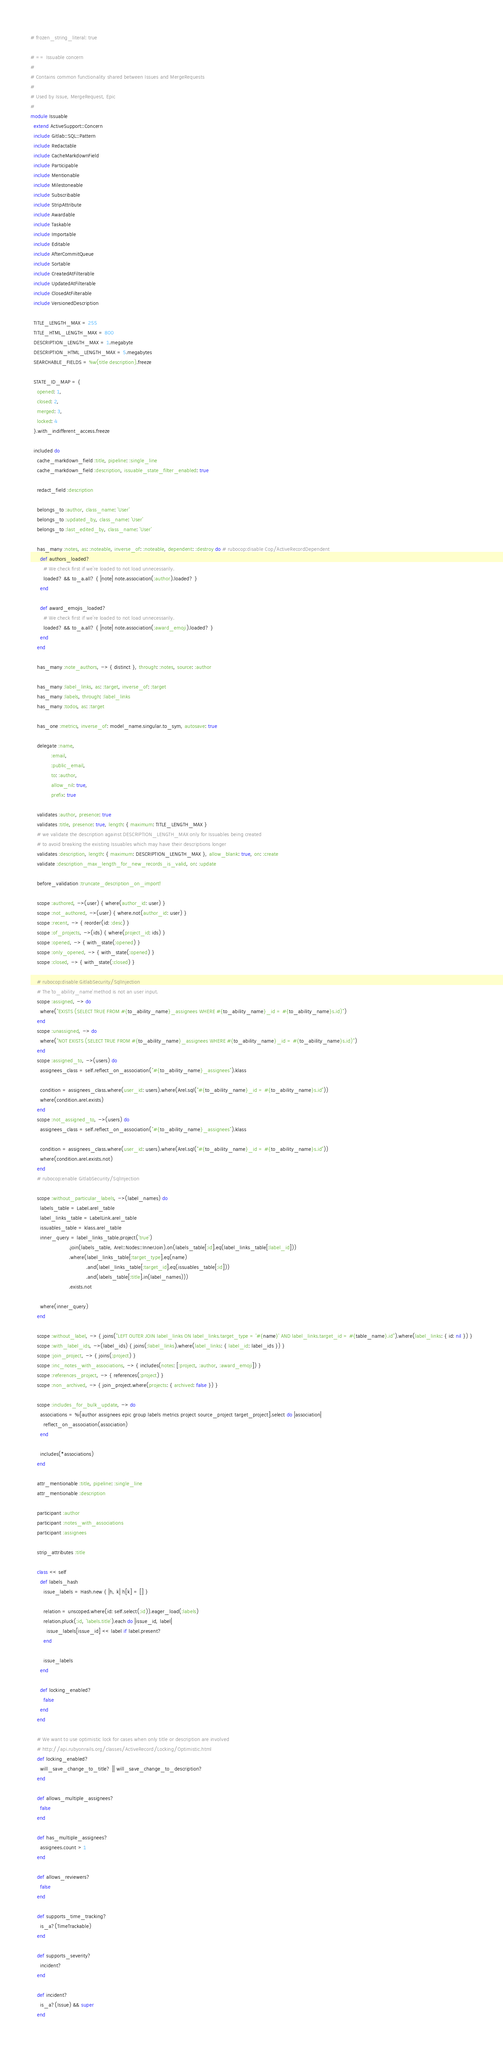<code> <loc_0><loc_0><loc_500><loc_500><_Ruby_># frozen_string_literal: true

# == Issuable concern
#
# Contains common functionality shared between Issues and MergeRequests
#
# Used by Issue, MergeRequest, Epic
#
module Issuable
  extend ActiveSupport::Concern
  include Gitlab::SQL::Pattern
  include Redactable
  include CacheMarkdownField
  include Participable
  include Mentionable
  include Milestoneable
  include Subscribable
  include StripAttribute
  include Awardable
  include Taskable
  include Importable
  include Editable
  include AfterCommitQueue
  include Sortable
  include CreatedAtFilterable
  include UpdatedAtFilterable
  include ClosedAtFilterable
  include VersionedDescription

  TITLE_LENGTH_MAX = 255
  TITLE_HTML_LENGTH_MAX = 800
  DESCRIPTION_LENGTH_MAX = 1.megabyte
  DESCRIPTION_HTML_LENGTH_MAX = 5.megabytes
  SEARCHABLE_FIELDS = %w(title description).freeze

  STATE_ID_MAP = {
    opened: 1,
    closed: 2,
    merged: 3,
    locked: 4
  }.with_indifferent_access.freeze

  included do
    cache_markdown_field :title, pipeline: :single_line
    cache_markdown_field :description, issuable_state_filter_enabled: true

    redact_field :description

    belongs_to :author, class_name: 'User'
    belongs_to :updated_by, class_name: 'User'
    belongs_to :last_edited_by, class_name: 'User'

    has_many :notes, as: :noteable, inverse_of: :noteable, dependent: :destroy do # rubocop:disable Cop/ActiveRecordDependent
      def authors_loaded?
        # We check first if we're loaded to not load unnecessarily.
        loaded? && to_a.all? { |note| note.association(:author).loaded? }
      end

      def award_emojis_loaded?
        # We check first if we're loaded to not load unnecessarily.
        loaded? && to_a.all? { |note| note.association(:award_emoji).loaded? }
      end
    end

    has_many :note_authors, -> { distinct }, through: :notes, source: :author

    has_many :label_links, as: :target, inverse_of: :target
    has_many :labels, through: :label_links
    has_many :todos, as: :target

    has_one :metrics, inverse_of: model_name.singular.to_sym, autosave: true

    delegate :name,
             :email,
             :public_email,
             to: :author,
             allow_nil: true,
             prefix: true

    validates :author, presence: true
    validates :title, presence: true, length: { maximum: TITLE_LENGTH_MAX }
    # we validate the description against DESCRIPTION_LENGTH_MAX only for Issuables being created
    # to avoid breaking the existing Issuables which may have their descriptions longer
    validates :description, length: { maximum: DESCRIPTION_LENGTH_MAX }, allow_blank: true, on: :create
    validate :description_max_length_for_new_records_is_valid, on: :update

    before_validation :truncate_description_on_import!

    scope :authored, ->(user) { where(author_id: user) }
    scope :not_authored, ->(user) { where.not(author_id: user) }
    scope :recent, -> { reorder(id: :desc) }
    scope :of_projects, ->(ids) { where(project_id: ids) }
    scope :opened, -> { with_state(:opened) }
    scope :only_opened, -> { with_state(:opened) }
    scope :closed, -> { with_state(:closed) }

    # rubocop:disable GitlabSecurity/SqlInjection
    # The `to_ability_name` method is not an user input.
    scope :assigned, -> do
      where("EXISTS (SELECT TRUE FROM #{to_ability_name}_assignees WHERE #{to_ability_name}_id = #{to_ability_name}s.id)")
    end
    scope :unassigned, -> do
      where("NOT EXISTS (SELECT TRUE FROM #{to_ability_name}_assignees WHERE #{to_ability_name}_id = #{to_ability_name}s.id)")
    end
    scope :assigned_to, ->(users) do
      assignees_class = self.reflect_on_association("#{to_ability_name}_assignees").klass

      condition = assignees_class.where(user_id: users).where(Arel.sql("#{to_ability_name}_id = #{to_ability_name}s.id"))
      where(condition.arel.exists)
    end
    scope :not_assigned_to, ->(users) do
      assignees_class = self.reflect_on_association("#{to_ability_name}_assignees").klass

      condition = assignees_class.where(user_id: users).where(Arel.sql("#{to_ability_name}_id = #{to_ability_name}s.id"))
      where(condition.arel.exists.not)
    end
    # rubocop:enable GitlabSecurity/SqlInjection

    scope :without_particular_labels, ->(label_names) do
      labels_table = Label.arel_table
      label_links_table = LabelLink.arel_table
      issuables_table = klass.arel_table
      inner_query = label_links_table.project('true')
                        .join(labels_table, Arel::Nodes::InnerJoin).on(labels_table[:id].eq(label_links_table[:label_id]))
                        .where(label_links_table[:target_type].eq(name)
                                   .and(label_links_table[:target_id].eq(issuables_table[:id]))
                                   .and(labels_table[:title].in(label_names)))
                        .exists.not

      where(inner_query)
    end

    scope :without_label, -> { joins("LEFT OUTER JOIN label_links ON label_links.target_type = '#{name}' AND label_links.target_id = #{table_name}.id").where(label_links: { id: nil }) }
    scope :with_label_ids, ->(label_ids) { joins(:label_links).where(label_links: { label_id: label_ids }) }
    scope :join_project, -> { joins(:project) }
    scope :inc_notes_with_associations, -> { includes(notes: [:project, :author, :award_emoji]) }
    scope :references_project, -> { references(:project) }
    scope :non_archived, -> { join_project.where(projects: { archived: false }) }

    scope :includes_for_bulk_update, -> do
      associations = %i[author assignees epic group labels metrics project source_project target_project].select do |association|
        reflect_on_association(association)
      end

      includes(*associations)
    end

    attr_mentionable :title, pipeline: :single_line
    attr_mentionable :description

    participant :author
    participant :notes_with_associations
    participant :assignees

    strip_attributes :title

    class << self
      def labels_hash
        issue_labels = Hash.new { |h, k| h[k] = [] }

        relation = unscoped.where(id: self.select(:id)).eager_load(:labels)
        relation.pluck(:id, 'labels.title').each do |issue_id, label|
          issue_labels[issue_id] << label if label.present?
        end

        issue_labels
      end

      def locking_enabled?
        false
      end
    end

    # We want to use optimistic lock for cases when only title or description are involved
    # http://api.rubyonrails.org/classes/ActiveRecord/Locking/Optimistic.html
    def locking_enabled?
      will_save_change_to_title? || will_save_change_to_description?
    end

    def allows_multiple_assignees?
      false
    end

    def has_multiple_assignees?
      assignees.count > 1
    end

    def allows_reviewers?
      false
    end

    def supports_time_tracking?
      is_a?(TimeTrackable)
    end

    def supports_severity?
      incident?
    end

    def incident?
      is_a?(Issue) && super
    end
</code> 